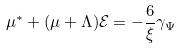Convert formula to latex. <formula><loc_0><loc_0><loc_500><loc_500>\mu ^ { * } + ( \mu + \Lambda ) { \mathcal { E } } = - \frac { 6 } { \xi } \gamma _ { \Psi }</formula> 